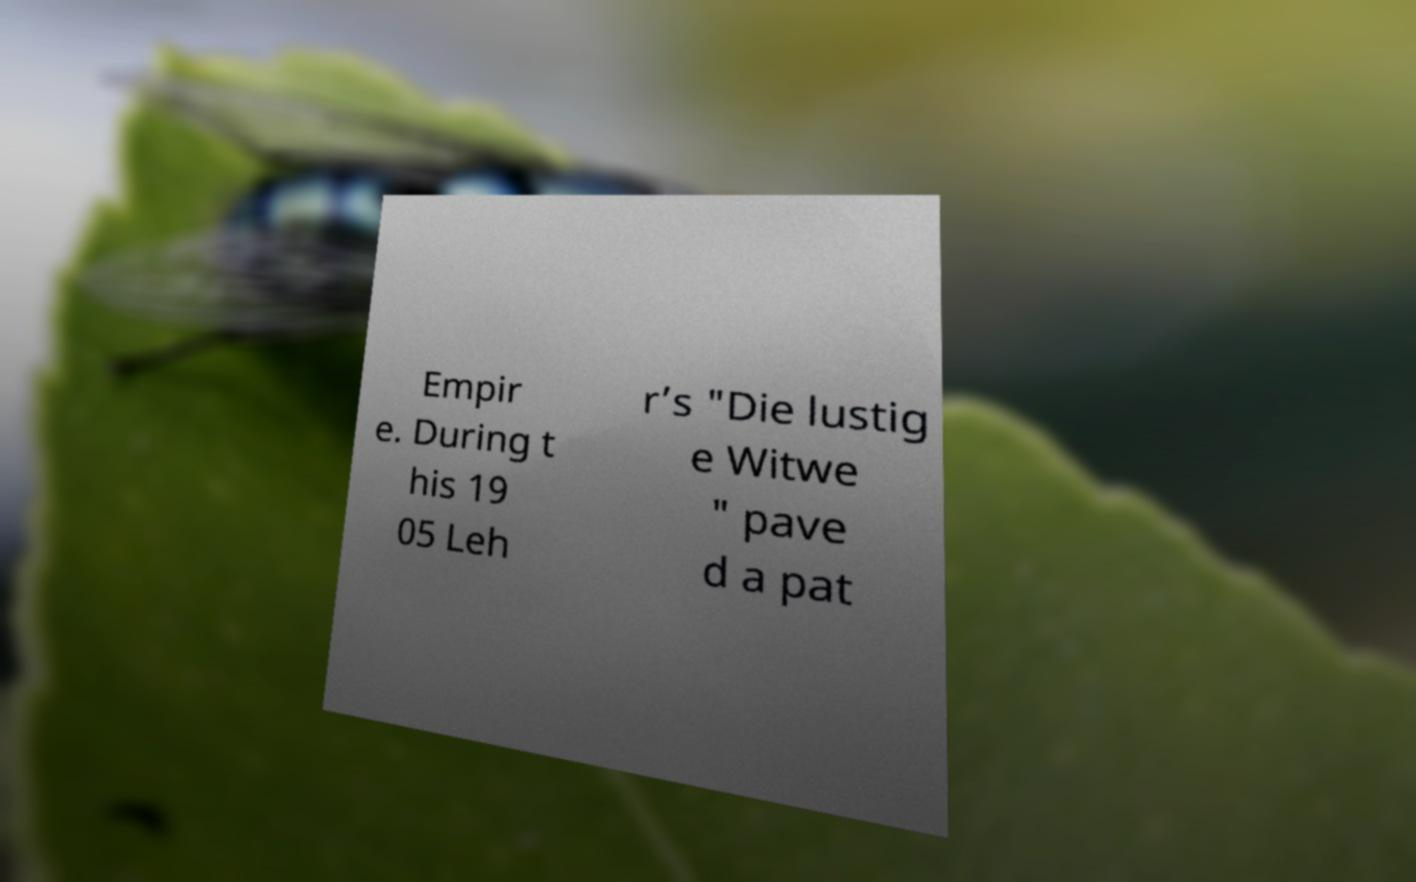Could you extract and type out the text from this image? Empir e. During t his 19 05 Leh r’s "Die lustig e Witwe " pave d a pat 